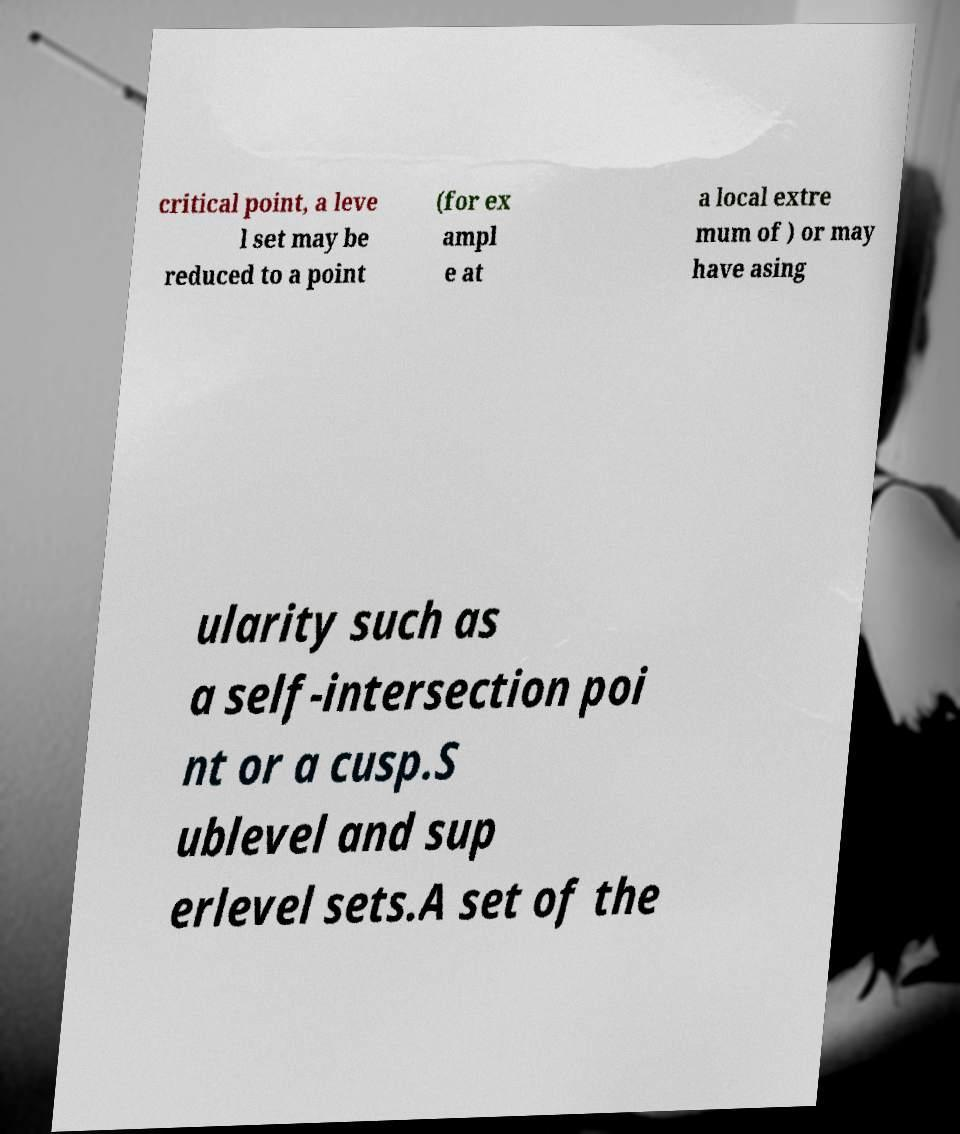Could you extract and type out the text from this image? critical point, a leve l set may be reduced to a point (for ex ampl e at a local extre mum of ) or may have asing ularity such as a self-intersection poi nt or a cusp.S ublevel and sup erlevel sets.A set of the 